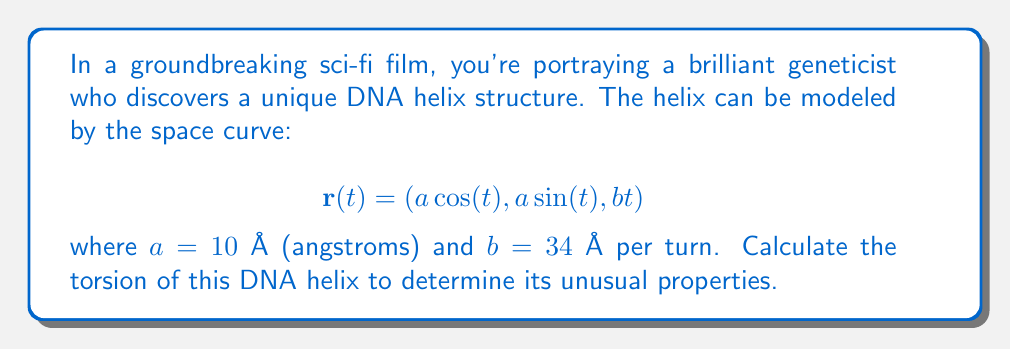Show me your answer to this math problem. To calculate the torsion of the DNA helix, we'll follow these steps:

1) The torsion $\tau$ of a space curve is given by:

   $$\tau = \frac{(\mathbf{r'} \times \mathbf{r''}) \cdot \mathbf{r'''}}{\|\mathbf{r'} \times \mathbf{r''}\|^2}$$

2) Let's calculate $\mathbf{r'}$, $\mathbf{r''}$, and $\mathbf{r'''}$:

   $$\mathbf{r'}(t) = (-a \sin(t), a \cos(t), b)$$
   $$\mathbf{r''}(t) = (-a \cos(t), -a \sin(t), 0)$$
   $$\mathbf{r'''}(t) = (a \sin(t), -a \cos(t), 0)$$

3) Now, let's compute $\mathbf{r'} \times \mathbf{r''}$:

   $$\mathbf{r'} \times \mathbf{r''} = (ab \sin(t), -ab \cos(t), a^2)$$

4) The magnitude of this cross product is:

   $$\|\mathbf{r'} \times \mathbf{r''}\| = \sqrt{(ab)^2 + a^4} = a\sqrt{b^2 + a^2}$$

5) Next, we calculate $(\mathbf{r'} \times \mathbf{r''}) \cdot \mathbf{r'''}$:

   $$(ab \sin(t), -ab \cos(t), a^2) \cdot (a \sin(t), -a \cos(t), 0) = a^2b$$

6) Now we can substitute these results into the torsion formula:

   $$\tau = \frac{a^2b}{(a\sqrt{b^2 + a^2})^2} = \frac{b}{a^2 + b^2}$$

7) Substituting the given values $a = 10$ Å and $b = 34$ Å:

   $$\tau = \frac{34}{10^2 + 34^2} = \frac{34}{1256} \approx 0.0271 \text{ Å}^{-1}$$
Answer: $\tau \approx 0.0271 \text{ Å}^{-1}$ 